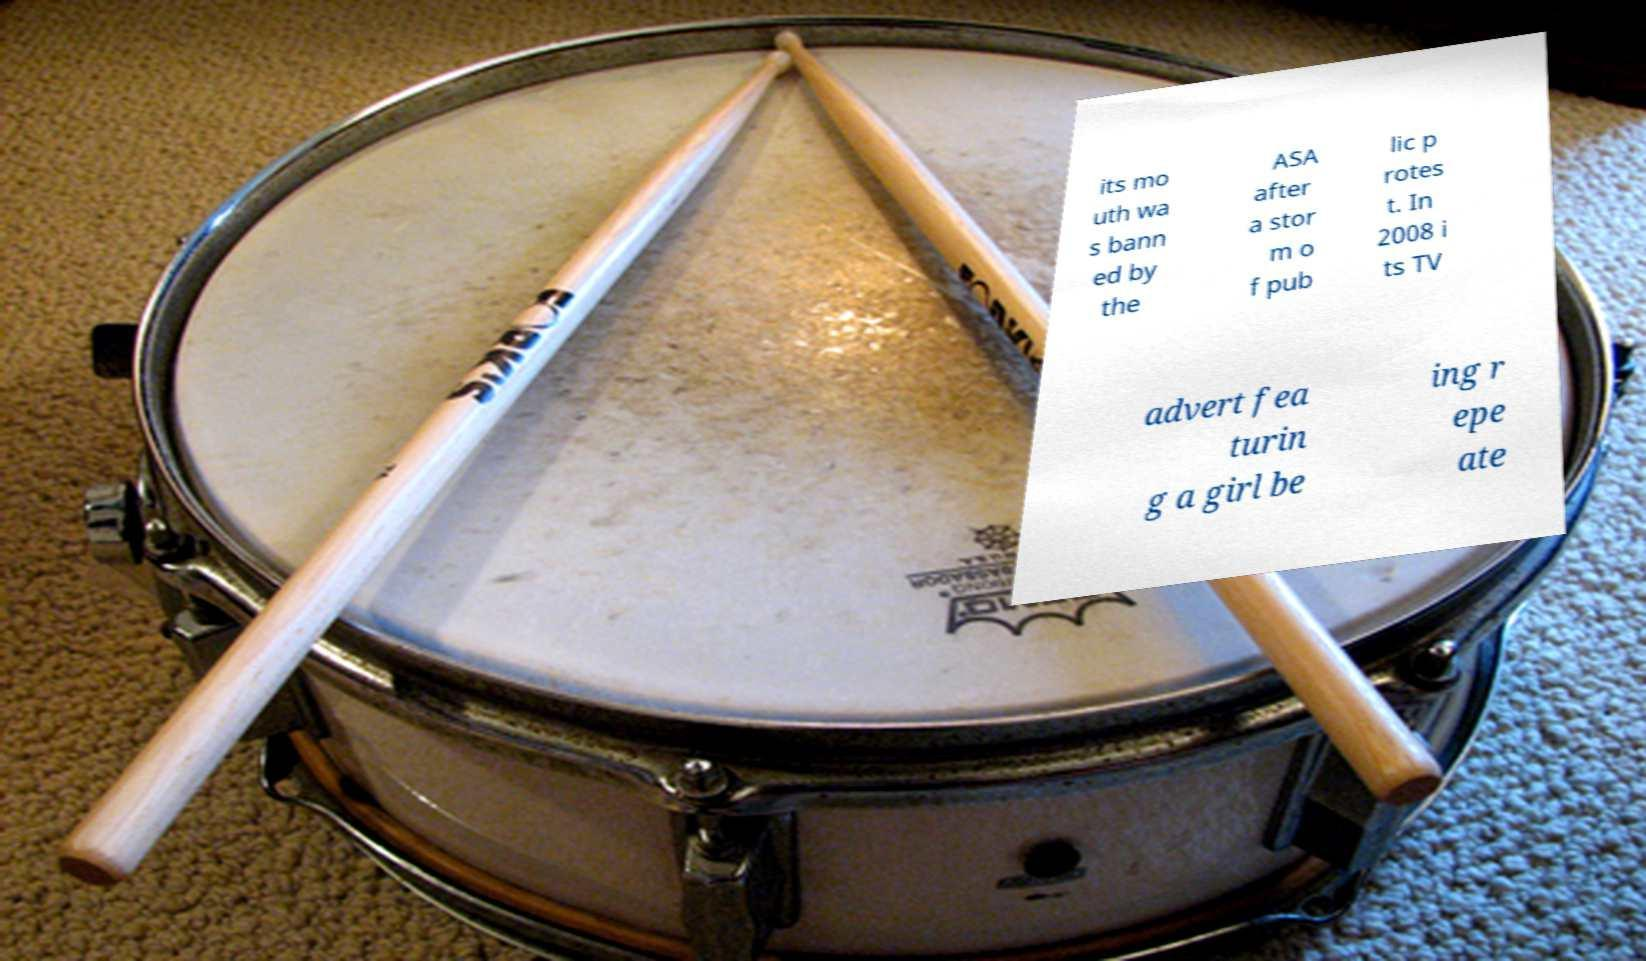I need the written content from this picture converted into text. Can you do that? its mo uth wa s bann ed by the ASA after a stor m o f pub lic p rotes t. In 2008 i ts TV advert fea turin g a girl be ing r epe ate 